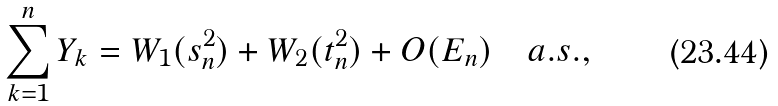<formula> <loc_0><loc_0><loc_500><loc_500>\sum _ { k = 1 } ^ { n } Y _ { k } = W _ { 1 } ( s _ { n } ^ { 2 } ) + W _ { 2 } ( t _ { n } ^ { 2 } ) + O ( E _ { n } ) \quad a . s . ,</formula> 